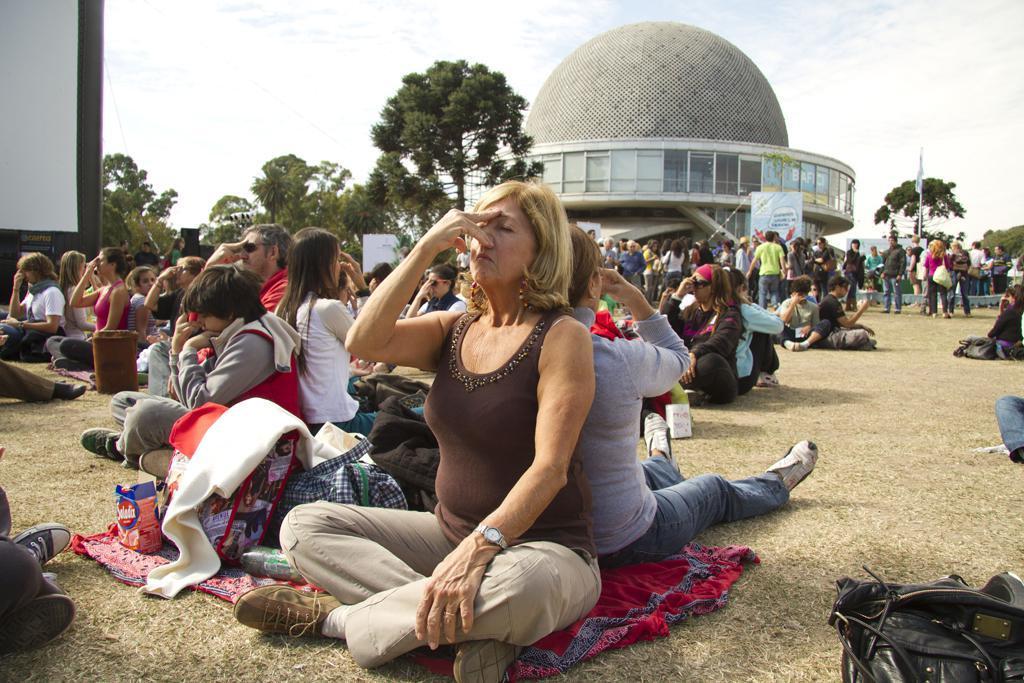How would you summarize this image in a sentence or two? In this image few persons are sitting on the grass land. Few persons are standing on the grassland. A woman wearing a brown top is holding her nose with her hand. Beside her there are few bags on the cloth which is on the grass land. Background there are few buildings and trees. Top of image there is sky with some clouds. 